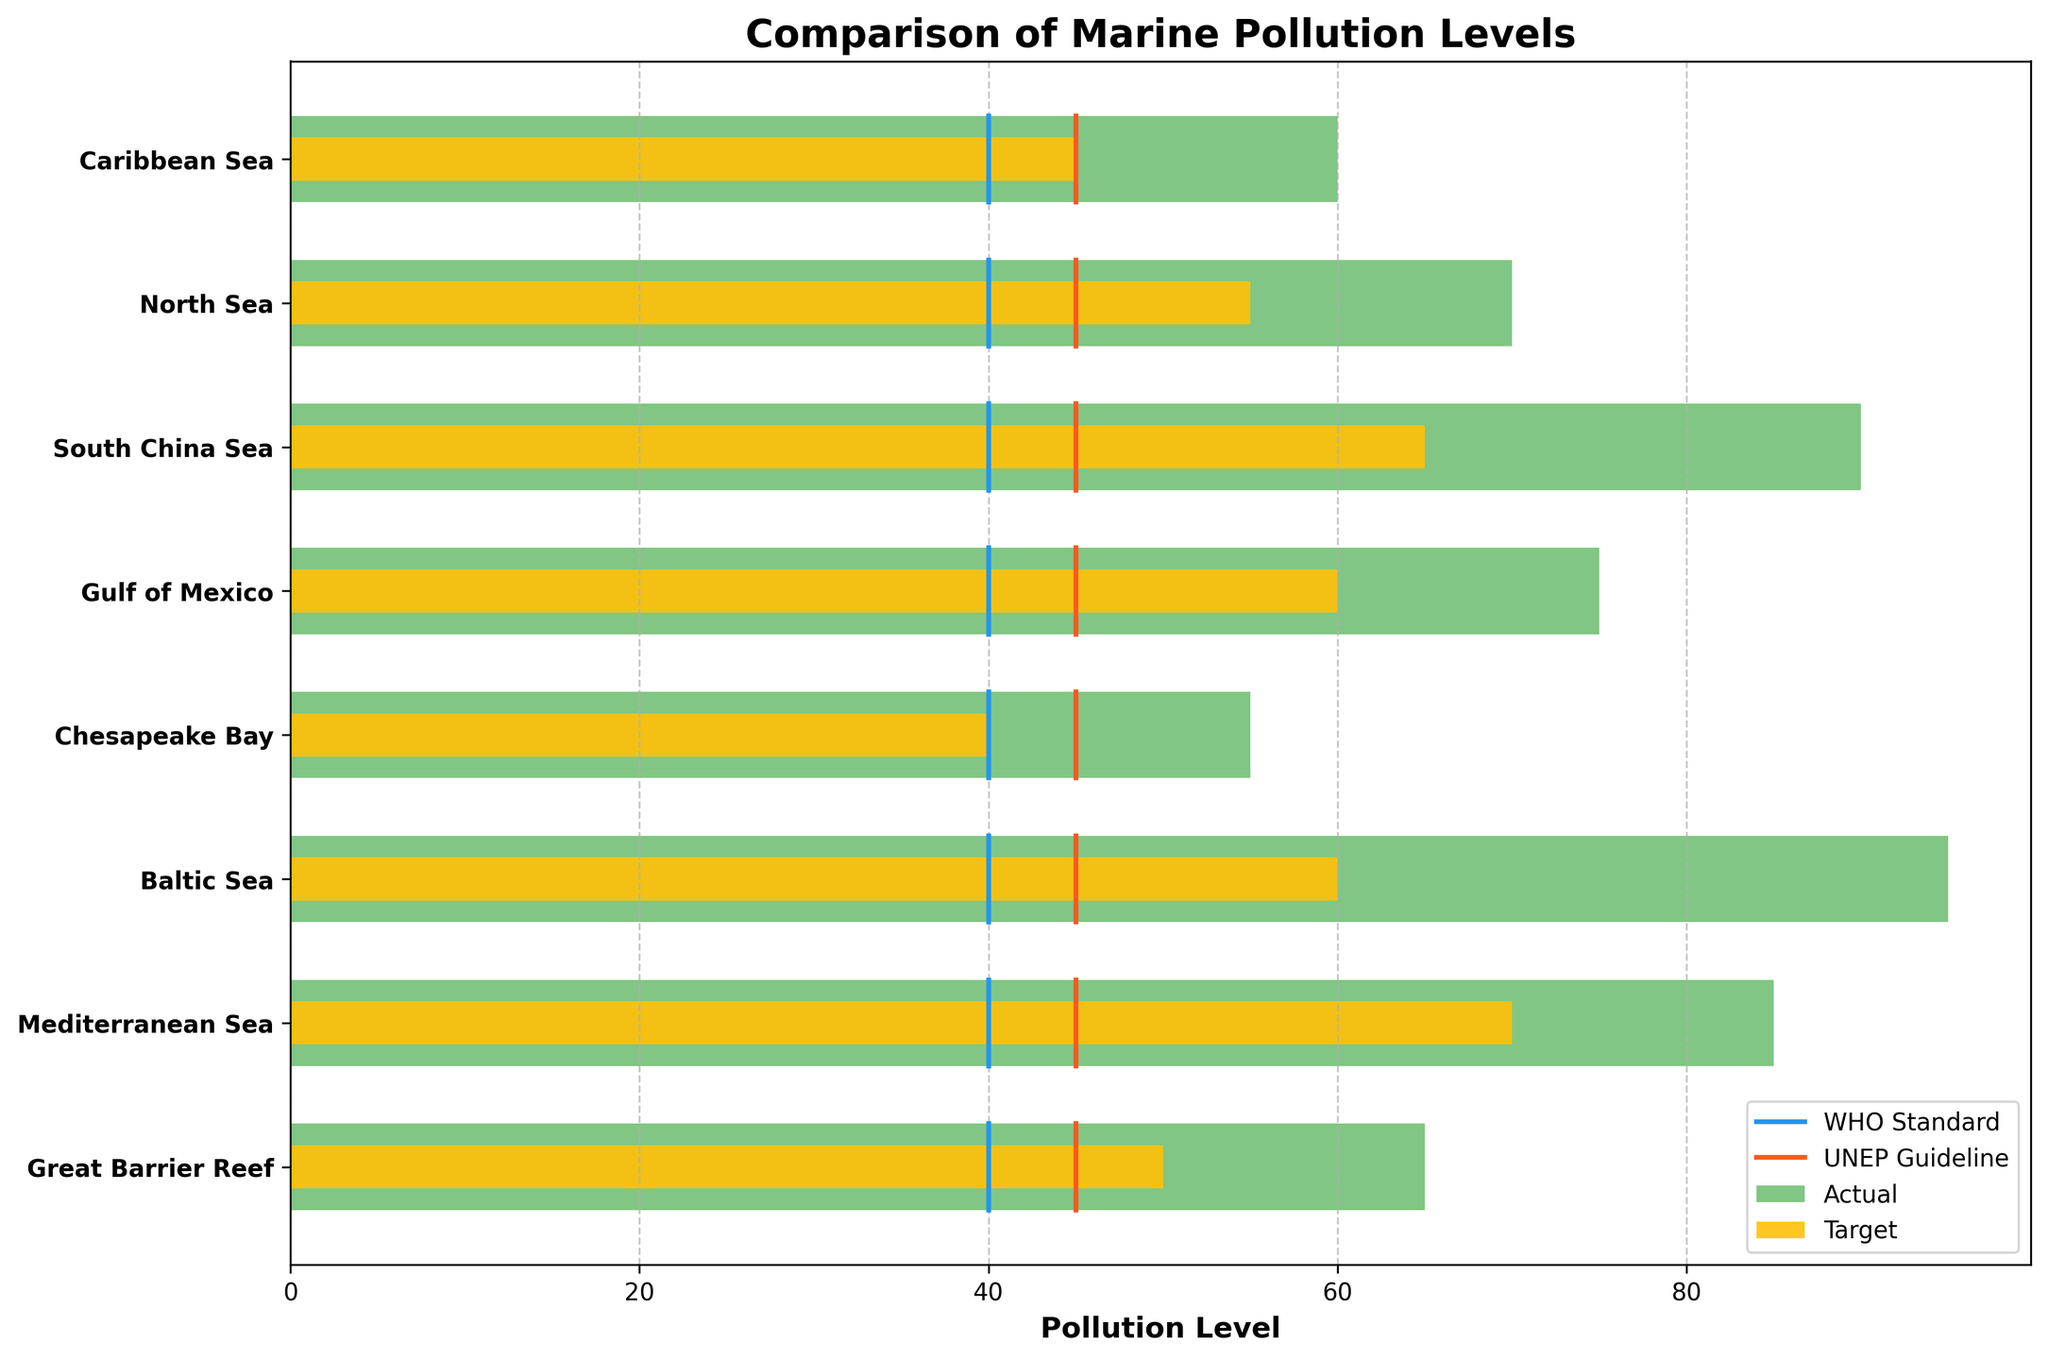What is the title of the chart? The title is located at the top of the chart. It reads "Comparison of Marine Pollution Levels".
Answer: Comparison of Marine Pollution Levels Which region has the highest actual pollution level? Look at the lengths of the green bars representing actual pollution levels. The longest bar corresponds to the Baltic Sea.
Answer: Baltic Sea What is the color used to represent the target pollution levels in the chart? The target pollution levels are represented by yellow bars.
Answer: Yellow How many regions are monitored in this chart? Count the number of regions listed on the y-axis. There are 8 regions in total.
Answer: 8 What's the difference between the actual pollution level and the target level in the Gulf of Mexico? Subtract the target level (60) from the actual level (75).
Answer: 15 How many regions exceed both the WHO standard and UNEP guideline? Count the number of regions where both the actual pollution level is greater than the WHO standard (40) and the UNEP guideline (45). All 8 regions exceed these standards.
Answer: 8 What's the average target pollution level across all monitored regions? Add the target levels for all regions (50 + 70 + 60 + 40 + 60 + 65 + 55 + 45) and divide by the number of regions (8).
Answer: 55.625 Which region has the smallest gap between its actual pollution level and the UNEP guideline? Calculate the difference between the actual pollution levels and the UNEP guideline for all regions, and find the smallest one. For the Chesapeake Bay, the difference is 55 - 45 = 10, which is the smallest.
Answer: Chesapeake Bay Is the actual pollution level of the North Sea higher or lower than the target level? Compare the green bar (actual pollution) with the yellow bar (target pollution) for the North Sea. The actual pollution level (70) is higher than the target level (55).
Answer: Higher Which region has an actual pollution level closest to the WHO standard? Calculate the absolute difference between the actual pollution levels and the WHO standard (40) for all regions and find the smallest. For the Chesapeake Bay, the difference is 55 - 40 = 15, which is the closest.
Answer: Chesapeake Bay 